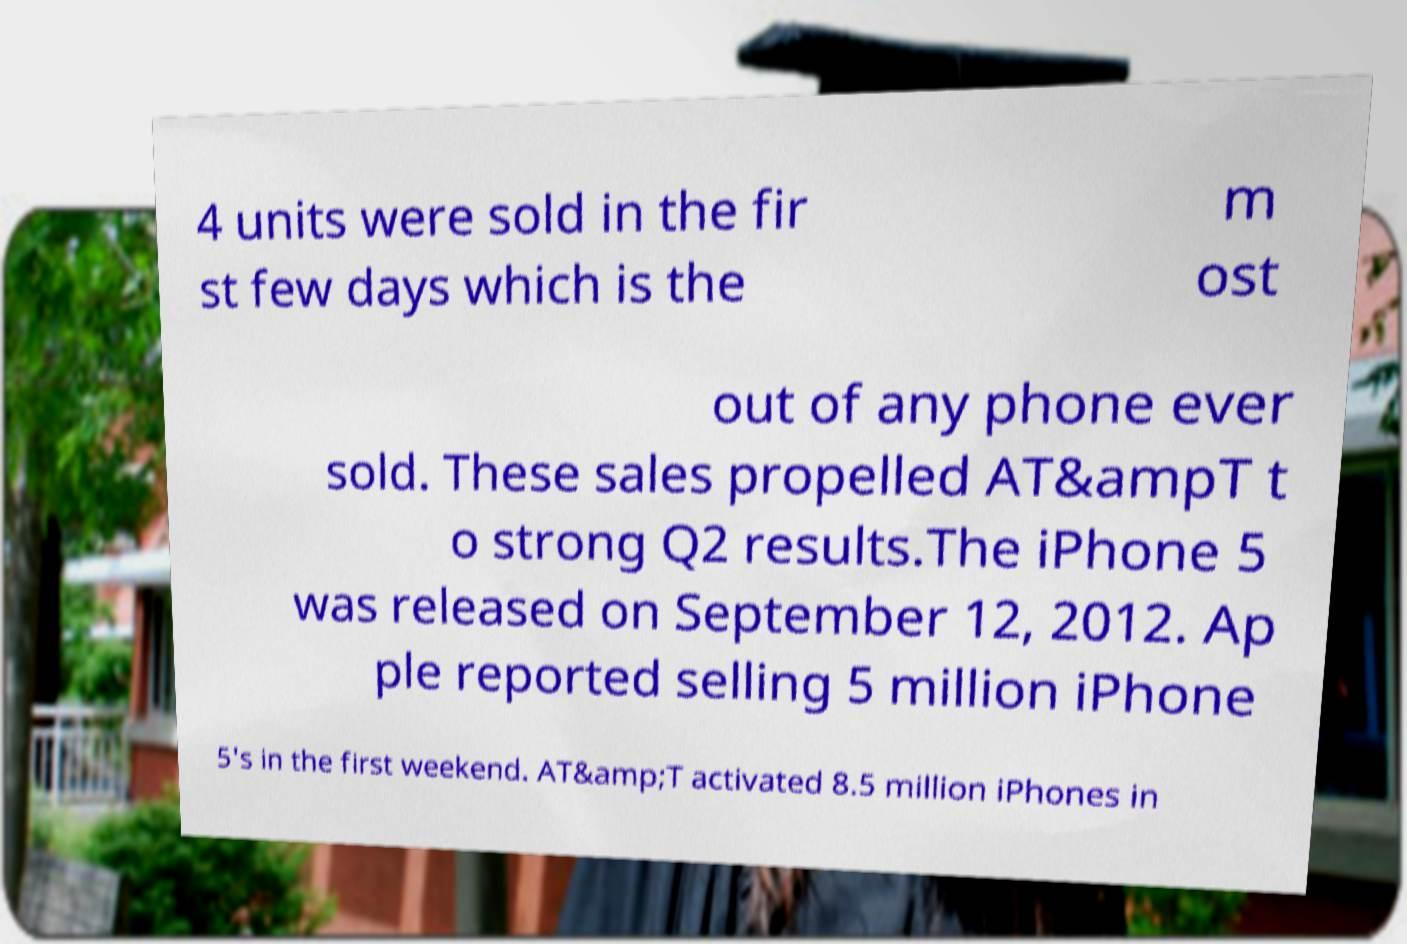I need the written content from this picture converted into text. Can you do that? 4 units were sold in the fir st few days which is the m ost out of any phone ever sold. These sales propelled AT&ampT t o strong Q2 results.The iPhone 5 was released on September 12, 2012. Ap ple reported selling 5 million iPhone 5's in the first weekend. AT&amp;T activated 8.5 million iPhones in 